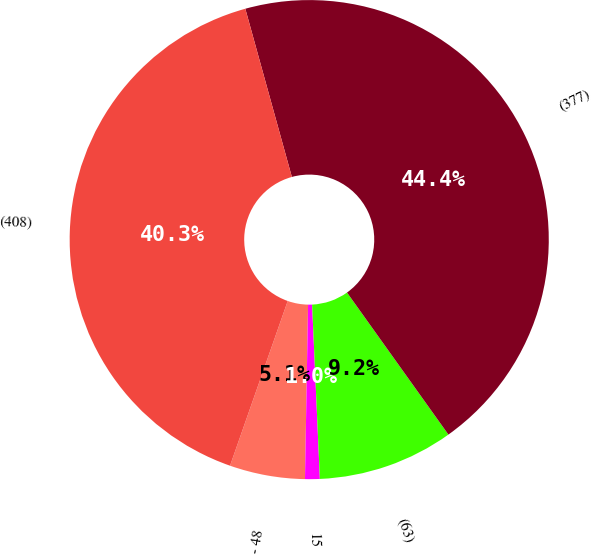Convert chart. <chart><loc_0><loc_0><loc_500><loc_500><pie_chart><fcel>- 48<fcel>15<fcel>(63)<fcel>(377)<fcel>(408)<nl><fcel>5.08%<fcel>0.99%<fcel>9.16%<fcel>44.43%<fcel>40.34%<nl></chart> 